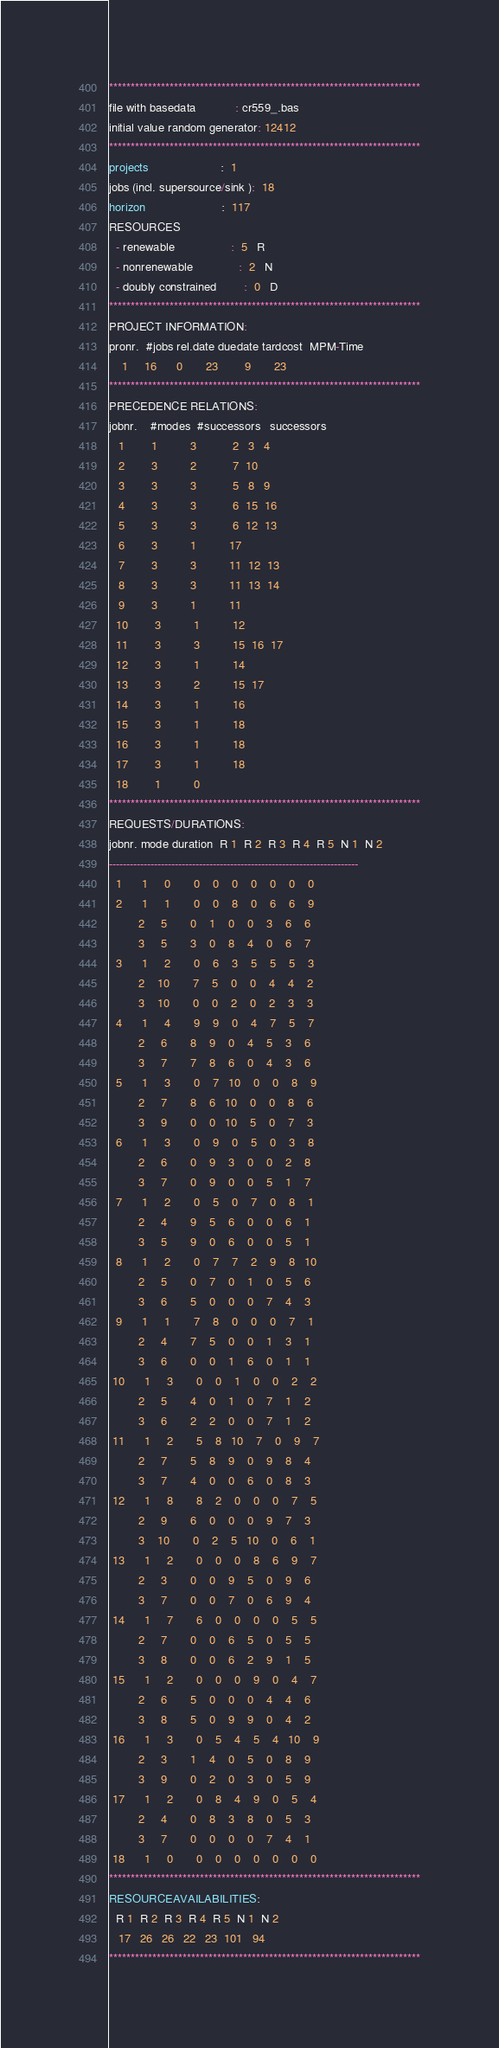<code> <loc_0><loc_0><loc_500><loc_500><_ObjectiveC_>************************************************************************
file with basedata            : cr559_.bas
initial value random generator: 12412
************************************************************************
projects                      :  1
jobs (incl. supersource/sink ):  18
horizon                       :  117
RESOURCES
  - renewable                 :  5   R
  - nonrenewable              :  2   N
  - doubly constrained        :  0   D
************************************************************************
PROJECT INFORMATION:
pronr.  #jobs rel.date duedate tardcost  MPM-Time
    1     16      0       23        9       23
************************************************************************
PRECEDENCE RELATIONS:
jobnr.    #modes  #successors   successors
   1        1          3           2   3   4
   2        3          2           7  10
   3        3          3           5   8   9
   4        3          3           6  15  16
   5        3          3           6  12  13
   6        3          1          17
   7        3          3          11  12  13
   8        3          3          11  13  14
   9        3          1          11
  10        3          1          12
  11        3          3          15  16  17
  12        3          1          14
  13        3          2          15  17
  14        3          1          16
  15        3          1          18
  16        3          1          18
  17        3          1          18
  18        1          0        
************************************************************************
REQUESTS/DURATIONS:
jobnr. mode duration  R 1  R 2  R 3  R 4  R 5  N 1  N 2
------------------------------------------------------------------------
  1      1     0       0    0    0    0    0    0    0
  2      1     1       0    0    8    0    6    6    9
         2     5       0    1    0    0    3    6    6
         3     5       3    0    8    4    0    6    7
  3      1     2       0    6    3    5    5    5    3
         2    10       7    5    0    0    4    4    2
         3    10       0    0    2    0    2    3    3
  4      1     4       9    9    0    4    7    5    7
         2     6       8    9    0    4    5    3    6
         3     7       7    8    6    0    4    3    6
  5      1     3       0    7   10    0    0    8    9
         2     7       8    6   10    0    0    8    6
         3     9       0    0   10    5    0    7    3
  6      1     3       0    9    0    5    0    3    8
         2     6       0    9    3    0    0    2    8
         3     7       0    9    0    0    5    1    7
  7      1     2       0    5    0    7    0    8    1
         2     4       9    5    6    0    0    6    1
         3     5       9    0    6    0    0    5    1
  8      1     2       0    7    7    2    9    8   10
         2     5       0    7    0    1    0    5    6
         3     6       5    0    0    0    7    4    3
  9      1     1       7    8    0    0    0    7    1
         2     4       7    5    0    0    1    3    1
         3     6       0    0    1    6    0    1    1
 10      1     3       0    0    1    0    0    2    2
         2     5       4    0    1    0    7    1    2
         3     6       2    2    0    0    7    1    2
 11      1     2       5    8   10    7    0    9    7
         2     7       5    8    9    0    9    8    4
         3     7       4    0    0    6    0    8    3
 12      1     8       8    2    0    0    0    7    5
         2     9       6    0    0    0    9    7    3
         3    10       0    2    5   10    0    6    1
 13      1     2       0    0    0    8    6    9    7
         2     3       0    0    9    5    0    9    6
         3     7       0    0    7    0    6    9    4
 14      1     7       6    0    0    0    0    5    5
         2     7       0    0    6    5    0    5    5
         3     8       0    0    6    2    9    1    5
 15      1     2       0    0    0    9    0    4    7
         2     6       5    0    0    0    4    4    6
         3     8       5    0    9    9    0    4    2
 16      1     3       0    5    4    5    4   10    9
         2     3       1    4    0    5    0    8    9
         3     9       0    2    0    3    0    5    9
 17      1     2       0    8    4    9    0    5    4
         2     4       0    8    3    8    0    5    3
         3     7       0    0    0    0    7    4    1
 18      1     0       0    0    0    0    0    0    0
************************************************************************
RESOURCEAVAILABILITIES:
  R 1  R 2  R 3  R 4  R 5  N 1  N 2
   17   26   26   22   23  101   94
************************************************************************
</code> 